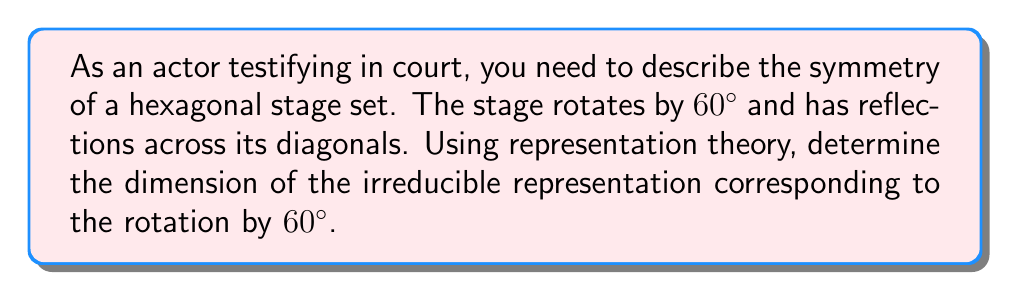Teach me how to tackle this problem. Let's approach this step-by-step:

1) The symmetry group of a regular hexagon is the dihedral group $D_6$, which has order 12.

2) $D_6$ has 6 rotations (including identity) and 6 reflections.

3) The character table for $D_6$ is:

   $$\begin{array}{c|cccccc}
   D_6 & E & C_6 & C_3 & C_2 & \sigma_d & \sigma_v \\
   \hline
   A_1 & 1 & 1 & 1 & 1 & 1 & 1 \\
   A_2 & 1 & 1 & 1 & 1 & -1 & -1 \\
   B_1 & 1 & -1 & 1 & -1 & 1 & -1 \\
   B_2 & 1 & -1 & 1 & -1 & -1 & 1 \\
   E_1 & 2 & 1 & -1 & -2 & 0 & 0 \\
   E_2 & 2 & -1 & -1 & 2 & 0 & 0
   \end{array}$$

4) The rotation by 60° corresponds to the $C_6$ conjugacy class.

5) Looking at the $C_6$ column, we see that the irreducible representations $A_1$, $A_2$, $E_1$ have character 1, while $B_1$, $B_2$, $E_2$ have character -1.

6) The dimension of an irreducible representation is given by the character of the identity element (column $E$).

7) Among the representations with character 1 for $C_6$, $E_1$ has the largest dimension, which is 2.

Therefore, the dimension of the irreducible representation corresponding to the rotation by 60° is 2.
Answer: 2 